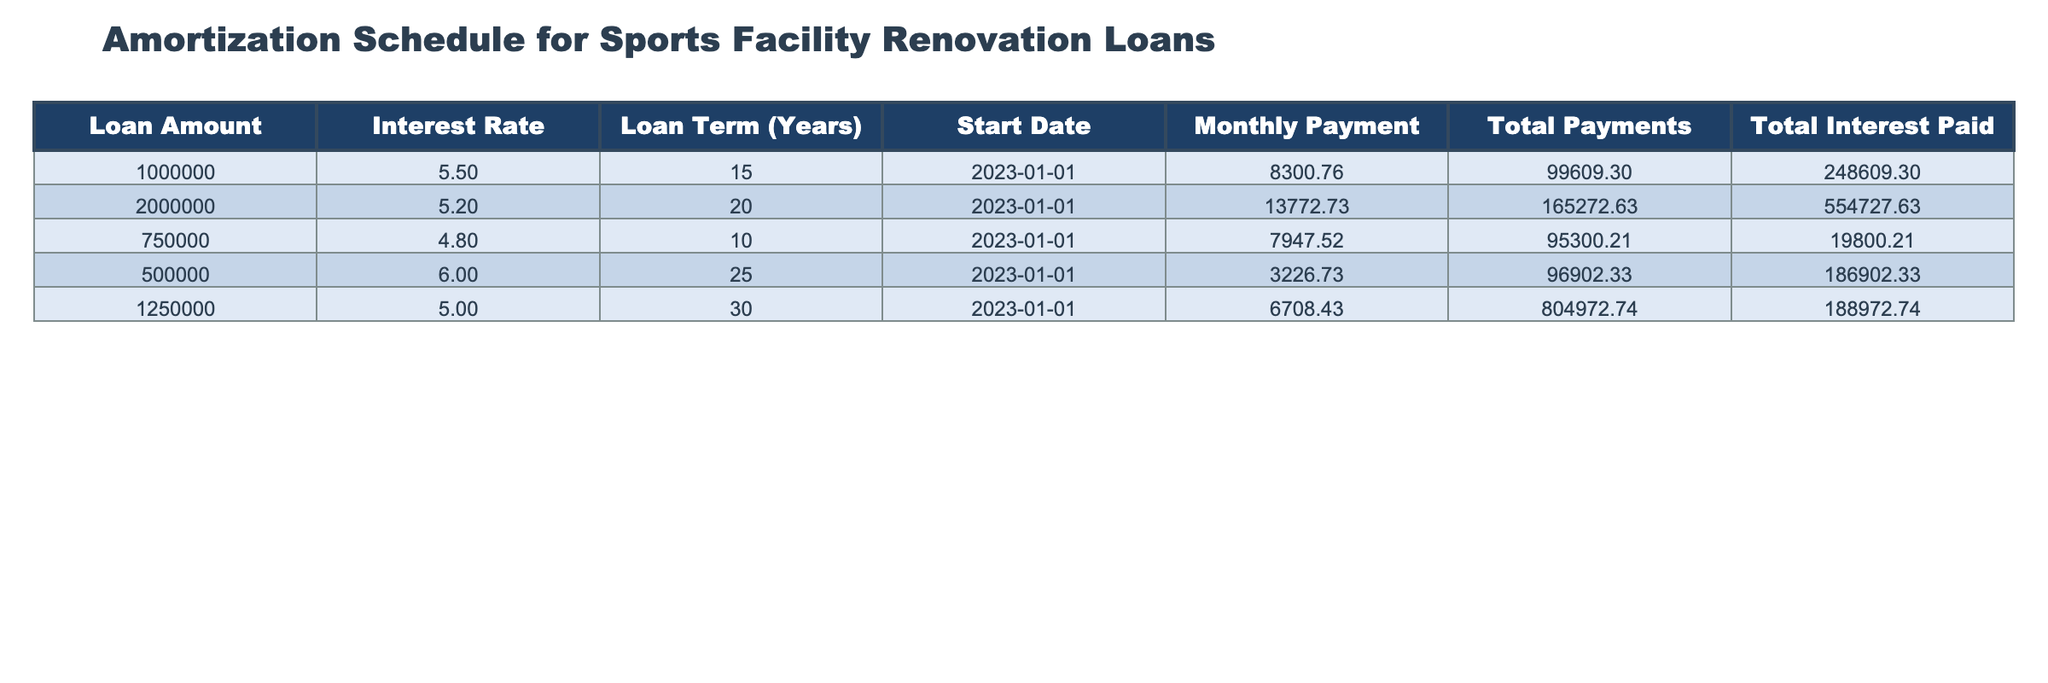What is the monthly payment for the loan of 2,000,000? The monthly payment is listed directly under the "Monthly Payment" column for the loan amount of 2,000,000. Referring to that row, it shows 13772.73.
Answer: 13772.73 What is the total interest paid for the loan of 750,000? The total interest paid is found in the "Total Interest Paid" column for the loan of 750,000. The value indicated is 19800.21.
Answer: 19800.21 Which loan has the highest total payments? To determine this, we compare the "Total Payments" column values. The loan of 1,250,000 shows the highest total payments amounting to 804972.74.
Answer: 1,250,000 Is the interest rate for the loan of 1,000,000 higher than that of the loan of 750,000? Comparing the interest rates from the "Interest Rate" column: 5.5 for 1,000,000 and 4.8 for 750,000. Since 5.5 is greater than 4.8, the answer is yes.
Answer: Yes What is the average monthly payment across all loans? To find the average monthly payment, we sum the monthly payments: (8300.76 + 13772.73 + 7947.52 + 3226.73 + 6708.43) = 40055.27. We have 5 loans, so the average is 40055.27 / 5 = 8011.05.
Answer: 8011.05 If you take the loan with the highest interest rate, what is the difference in total payments compared to the loan with the lowest interest rate? The highest interest rate is 6.0 for 500,000 with total payments of 96902.33. The lowest interest rate is 4.8 for 750,000 with total payments of 95300.21. The difference in total payments is 96902.33 - 95300.21 = 602.12.
Answer: 602.12 For which loan term (in years) is the total interest paid less than 200,000? Looking at the "Total Interest Paid" column, the loans of 750,000 (19800.21) and 1,000,000 (248609.30) have less than 200,000, so the loan terms for them are 10 and 15 years, respectively. Thus the qualifying terms are 10 and 15 years.
Answer: 10 and 15 Is it true that the total payments for loans with a term of 20 years or more exceed 600,000? Checking the "Total Payments" for loans with 20 and 30 year terms: 165272.63 for 2,000,000 and 804972.74 for 1,250,000. The total is 165272.63 + 804972.74 = 970245.37, which exceeds 600,000. Therefore, the statement is true.
Answer: Yes 